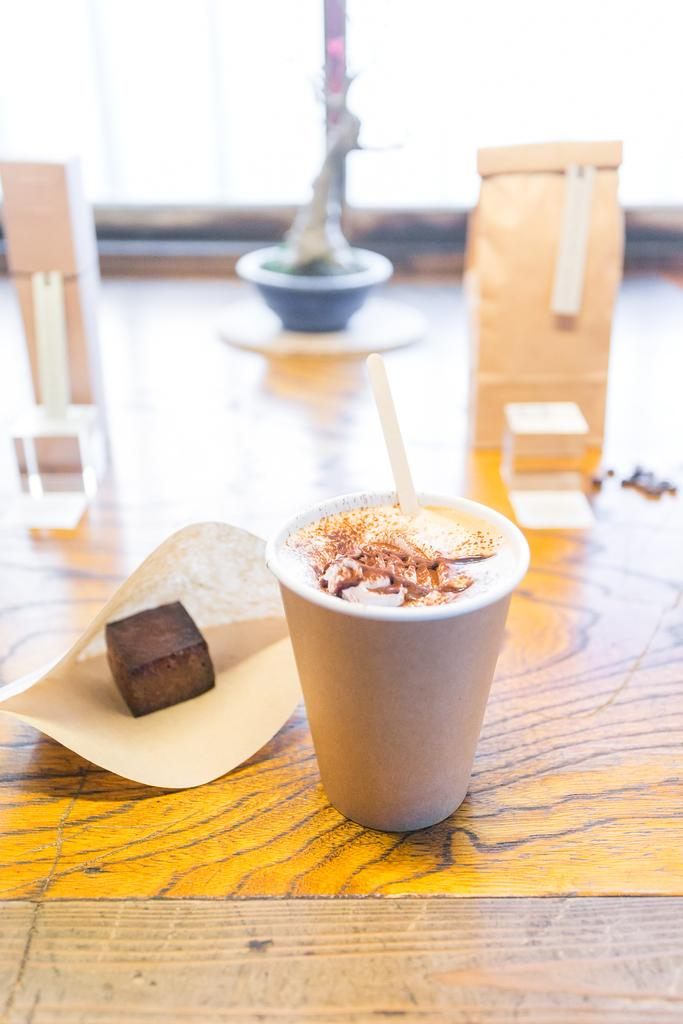What is in the glass that is visible in the image? There is a drink in the glass in the image. What other object is beside the glass? There is a cube beside the glass. Where are the glass and cube located? The glass and cube are on a table. Can you describe the background of the image? There are objects in the background of the image. What type of caption is written on the glass in the image? There is no caption written on the glass in the image. Can you see a carriage in the background of the image? There is no carriage present in the image. 